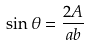<formula> <loc_0><loc_0><loc_500><loc_500>\sin \theta = \frac { 2 A } { a b }</formula> 